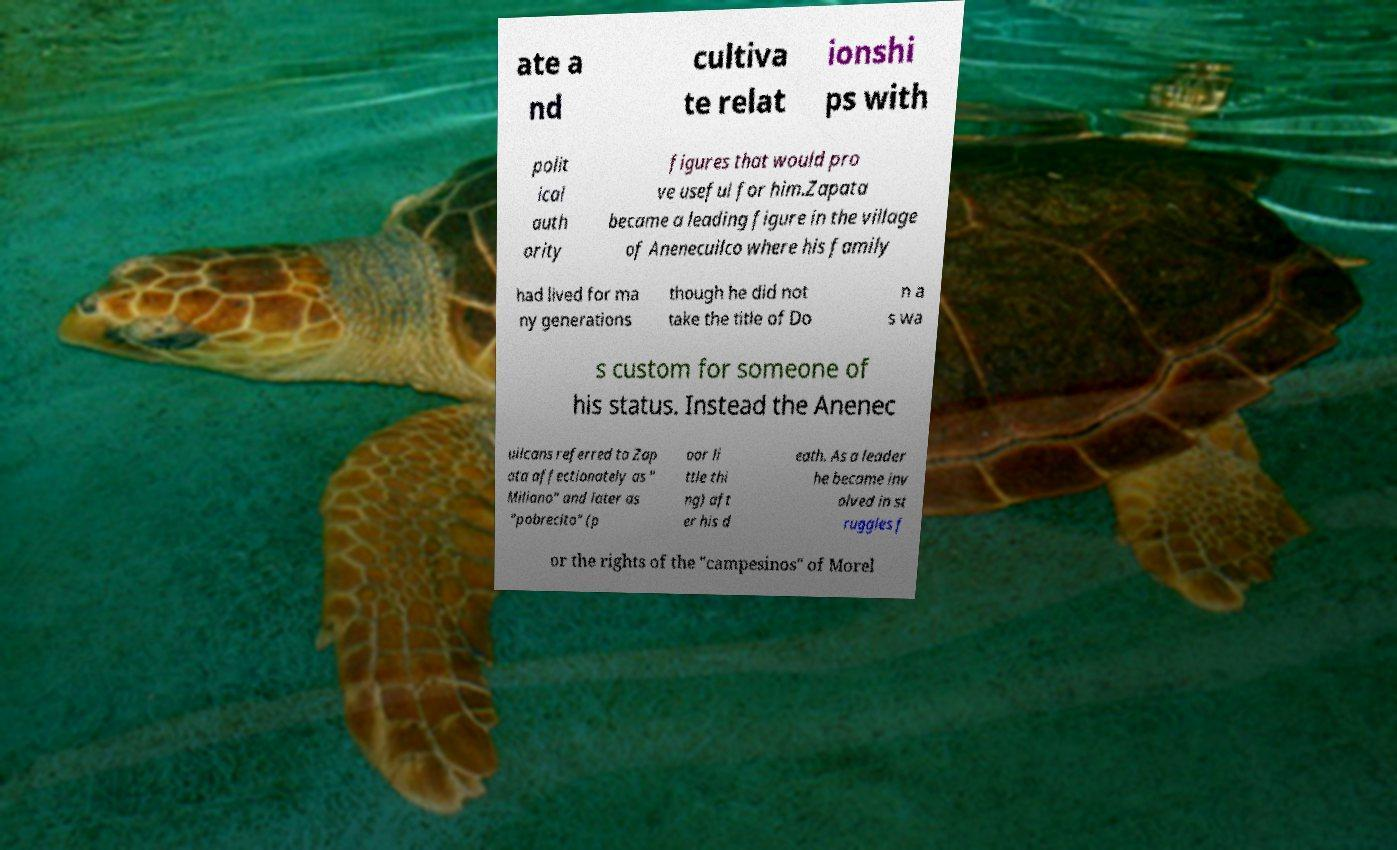Please read and relay the text visible in this image. What does it say? ate a nd cultiva te relat ionshi ps with polit ical auth ority figures that would pro ve useful for him.Zapata became a leading figure in the village of Anenecuilco where his family had lived for ma ny generations though he did not take the title of Do n a s wa s custom for someone of his status. Instead the Anenec uilcans referred to Zap ata affectionately as " Miliano" and later as "pobrecito" (p oor li ttle thi ng) aft er his d eath. As a leader he became inv olved in st ruggles f or the rights of the "campesinos" of Morel 